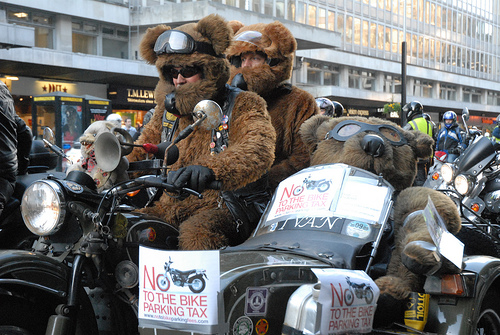Identify and read out the text in this image. NO TO BIKE TAX PARKING THE No PARKING Tax BIKE THE TO TTOIL 09 TVAN No PARKING TAX BIKE THE TO TMLLEW 